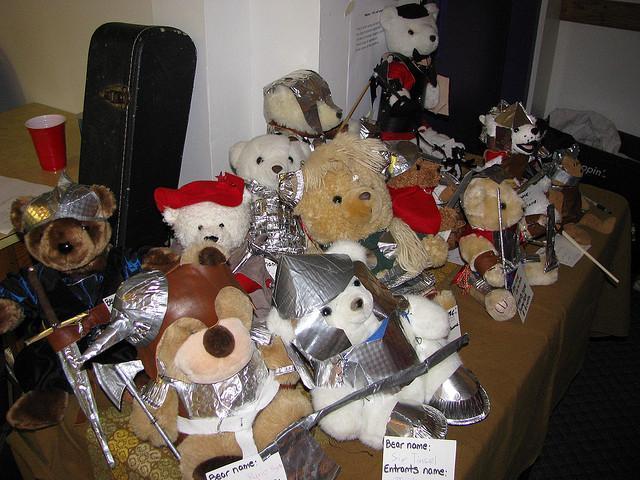How many teddy bears are there?
Give a very brief answer. 11. How many people are running??
Give a very brief answer. 0. 